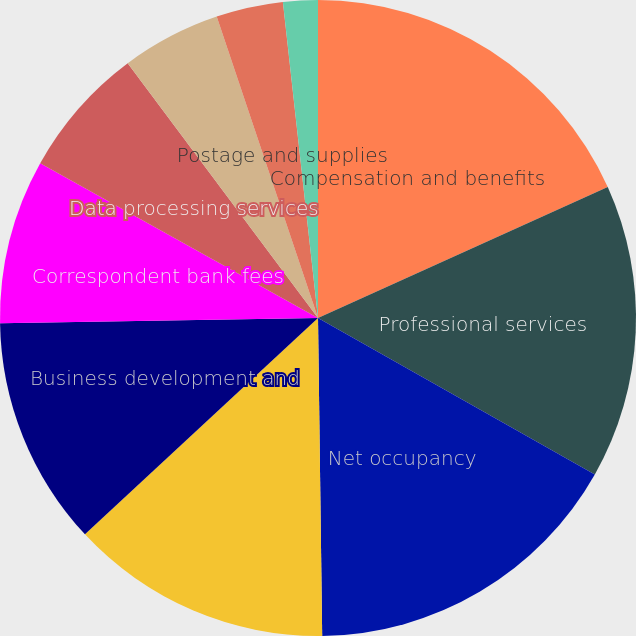Convert chart. <chart><loc_0><loc_0><loc_500><loc_500><pie_chart><fcel>Compensation and benefits<fcel>Professional services<fcel>Net occupancy<fcel>Furniture and equipment<fcel>Business development and<fcel>Correspondent bank fees<fcel>Data processing services<fcel>Telephone<fcel>Postage and supplies<fcel>Tax credit fund amortization<nl><fcel>18.24%<fcel>14.95%<fcel>16.6%<fcel>13.3%<fcel>11.65%<fcel>8.35%<fcel>6.7%<fcel>5.05%<fcel>3.4%<fcel>1.76%<nl></chart> 